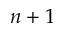<formula> <loc_0><loc_0><loc_500><loc_500>n + 1</formula> 